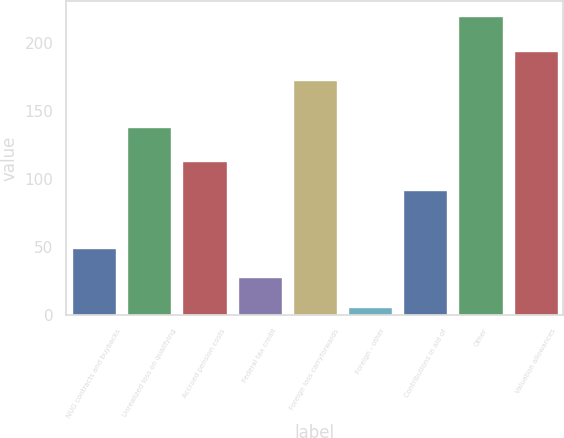Convert chart to OTSL. <chart><loc_0><loc_0><loc_500><loc_500><bar_chart><fcel>NUG contracts and buybacks<fcel>Unrealized loss on qualifying<fcel>Accrued pension costs<fcel>Federal tax credit<fcel>Foreign loss carryforwards<fcel>Foreign - other<fcel>Contributions in aid of<fcel>Other<fcel>Valuation allowances<nl><fcel>48.8<fcel>138<fcel>113.4<fcel>27.4<fcel>173<fcel>6<fcel>92<fcel>220<fcel>194.4<nl></chart> 